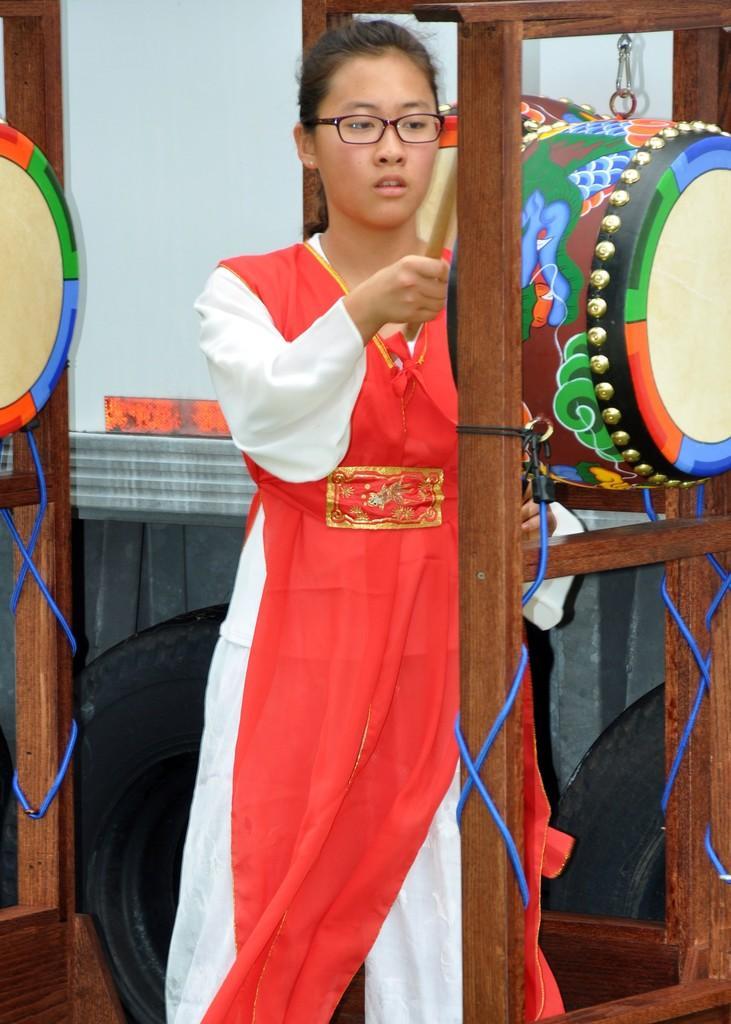Could you give a brief overview of what you see in this image? In this picture I can see a woman wearing a red color dress and in front of her I can see a wooden stand , in between stand I can see a drum and I can see a drum on left side 